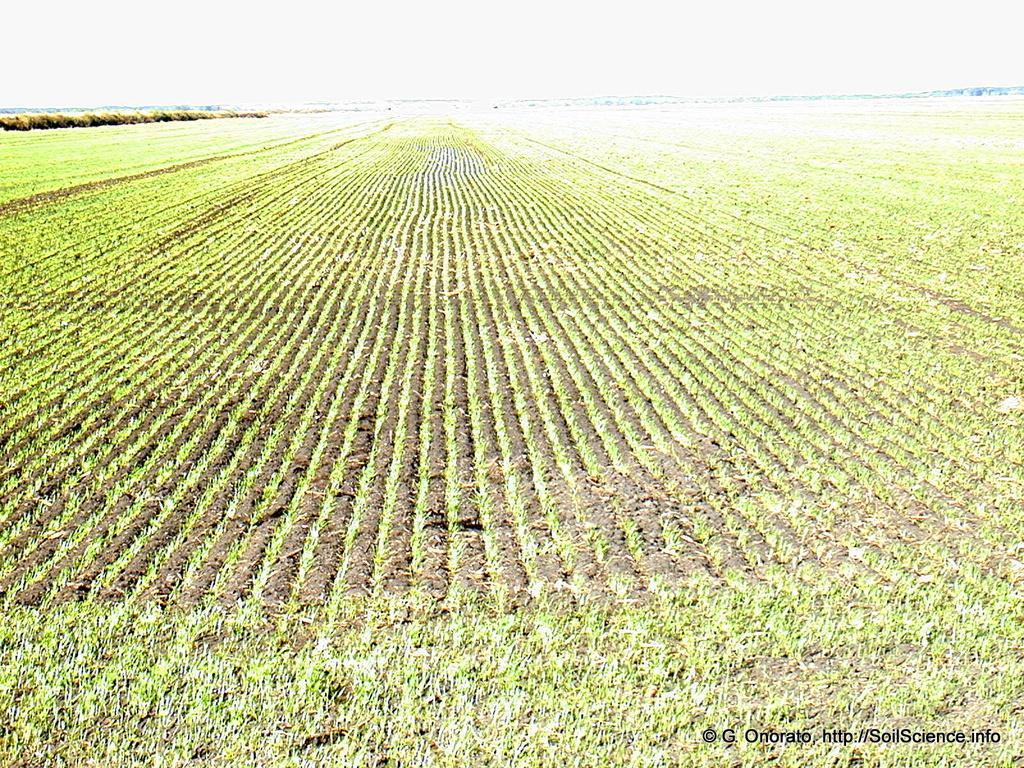Could you give a brief overview of what you see in this image? In this image, we can see fields and at the bottom, there is some text. 